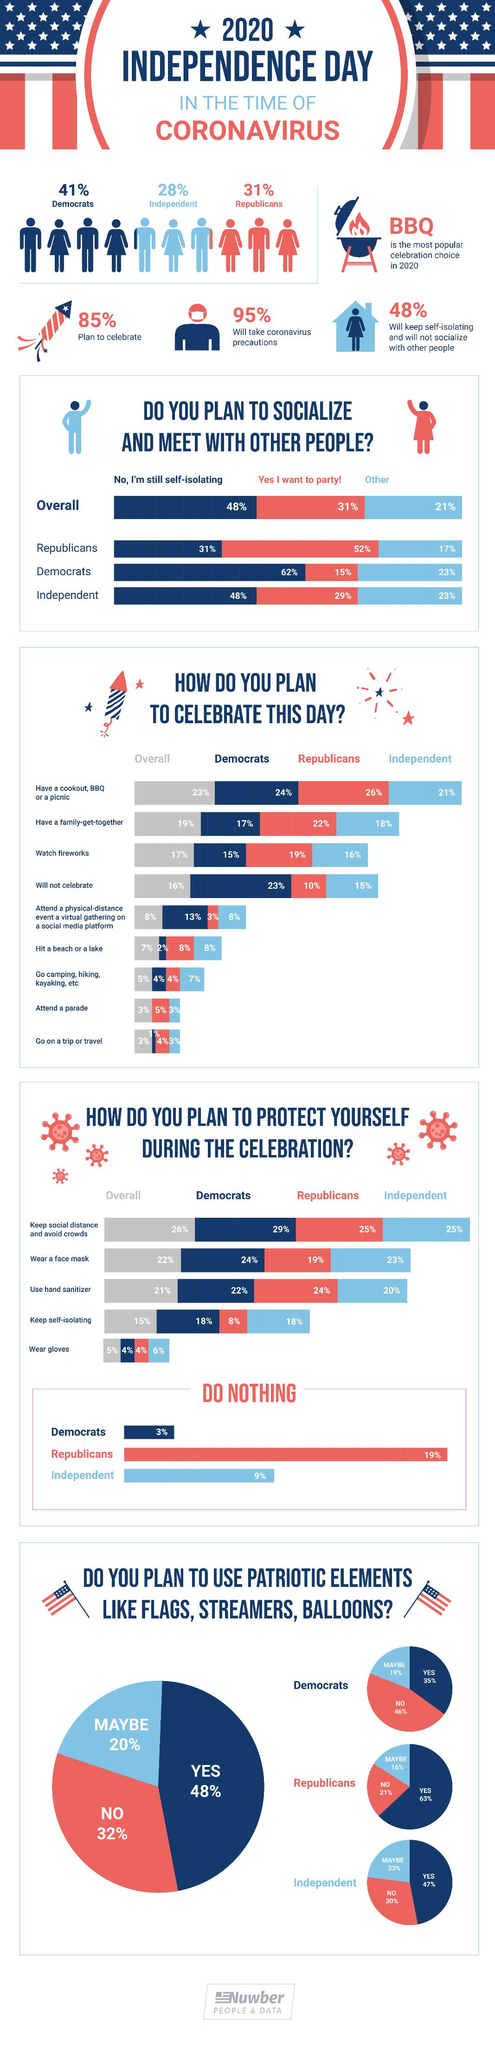Give some essential details in this illustration. A recent survey has revealed that 31% of Republicans are still following self-isolation as a COVID-19 precaution instead of partying. According to a recent survey, it is projected that 95% of Americans will take COVID-19 precautions while celebrating Independence Day in 2020. According to a recent survey, 41% of Americans identify as Democrats. According to a survey, 15% of Democrats expressed an interest in attending a party as a part of Independence Day celebrations. According to the survey, 22% of Republicans plan to have a family get-together to celebrate Independence Day. 